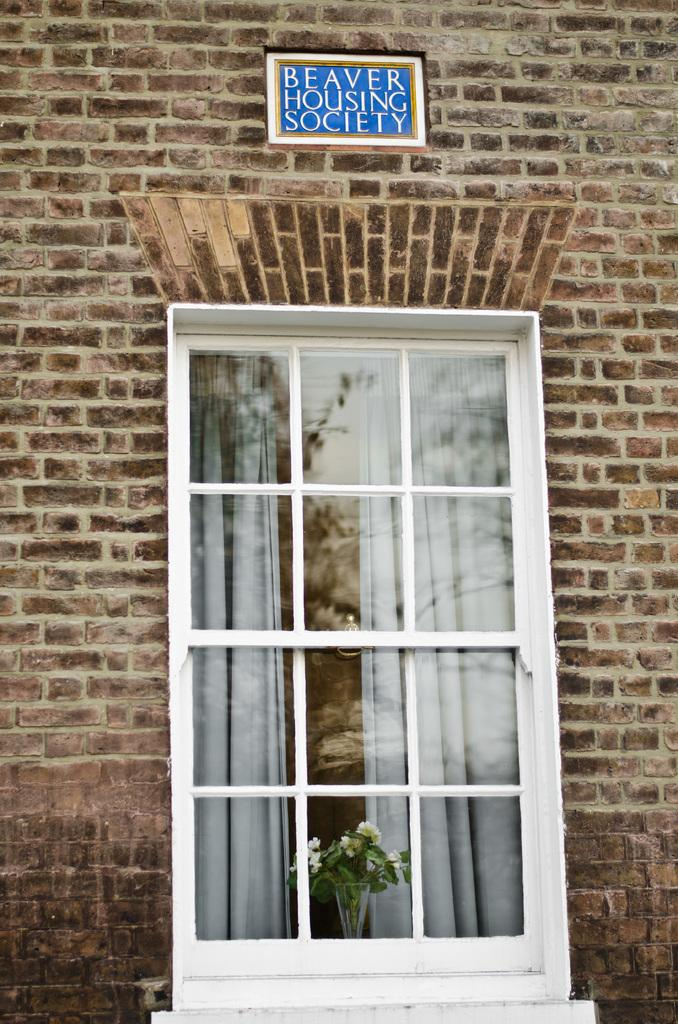What type of structure can be seen in the image? There is a wall in the image. Is there any opening in the wall? Yes, there is a window in the image. What is placed on the wall? There is a flower vase placed on the wall. What is visible at the top of the image? There is a board at the top of the image. How many men are playing in the hall in the image? There are no men or a hall present in the image. 